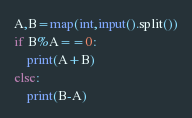Convert code to text. <code><loc_0><loc_0><loc_500><loc_500><_Python_>A,B=map(int,input().split())
if B%A==0:
    print(A+B)
else:
    print(B-A)</code> 